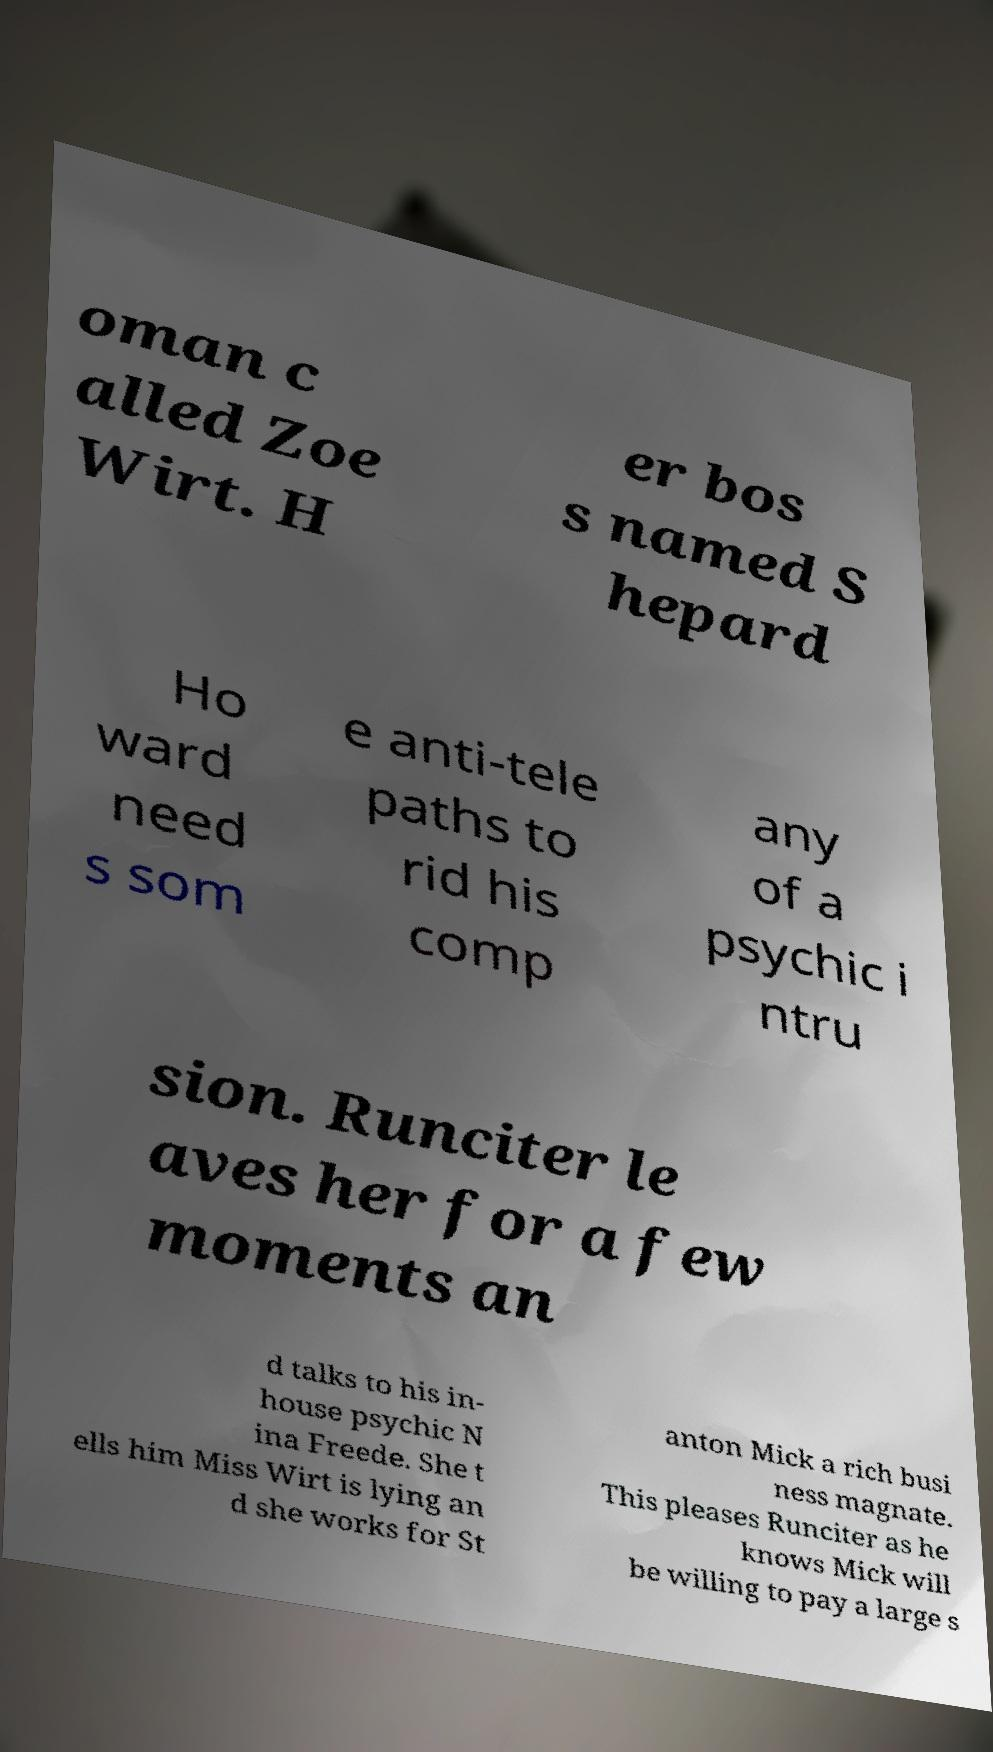Could you extract and type out the text from this image? oman c alled Zoe Wirt. H er bos s named S hepard Ho ward need s som e anti-tele paths to rid his comp any of a psychic i ntru sion. Runciter le aves her for a few moments an d talks to his in- house psychic N ina Freede. She t ells him Miss Wirt is lying an d she works for St anton Mick a rich busi ness magnate. This pleases Runciter as he knows Mick will be willing to pay a large s 